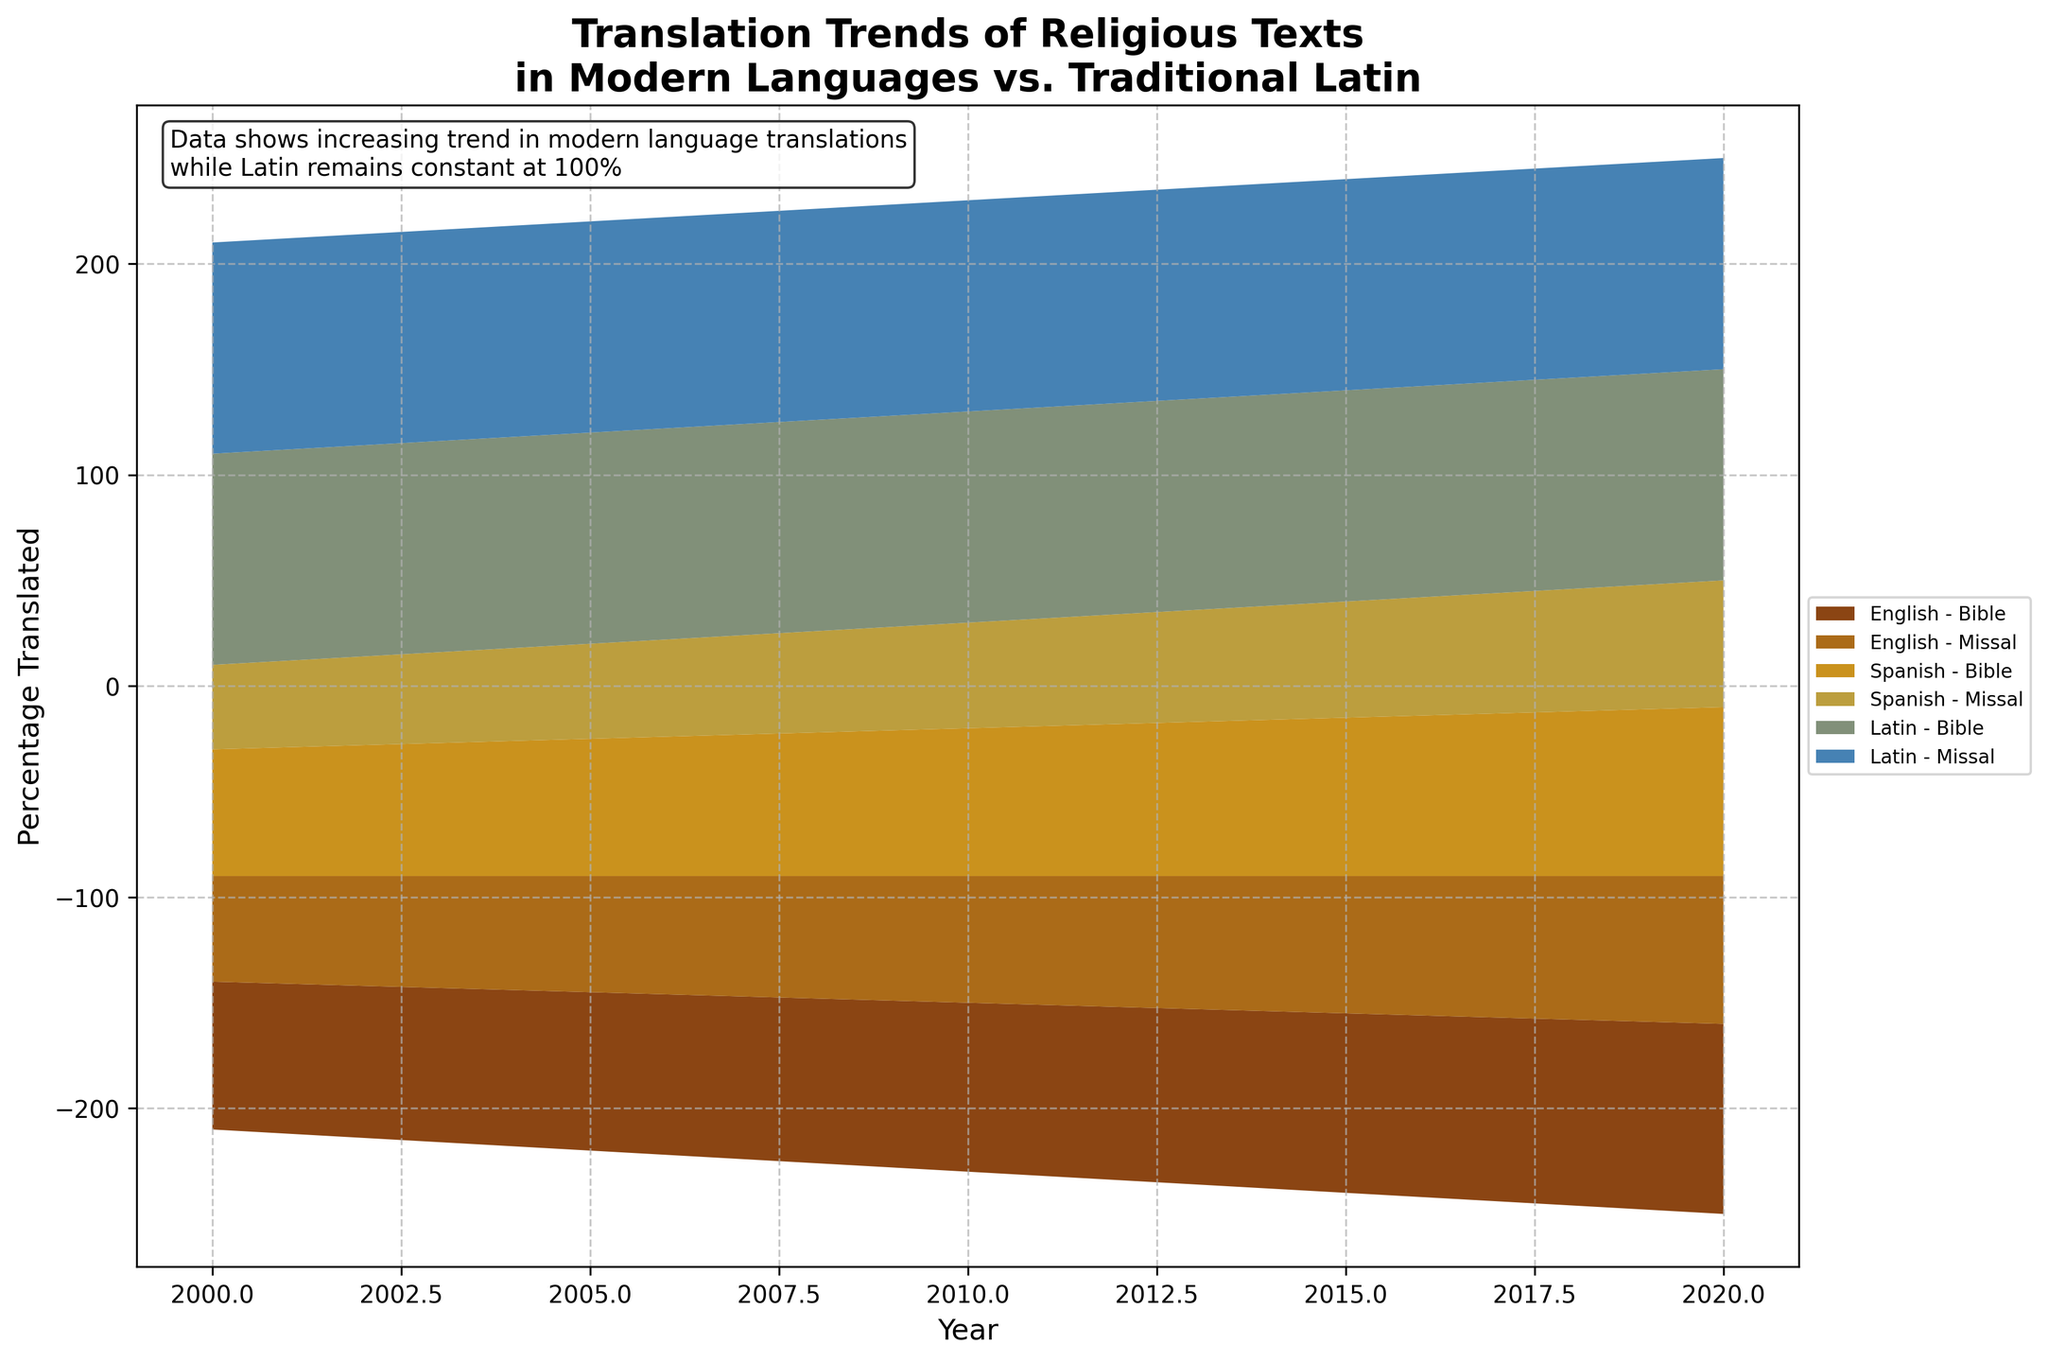What is the general trend in the translation of the Bible into English over the given years? The percentage of Bible translation into English shows a steady increase from 70% in 2000 to 90% in 2020. By looking at the figure, one can observe this upward trend.
Answer: Increasing What percentage of the Missal is translated into Spanish in 2010? By locating the data point for Spanish and Missal in the year 2010, we see that the percentage translated is 50%.
Answer: 50% How does the trend of Bible translation into Spanish compare to that into English? When comparing the trend lines, both English and Spanish show an upward trend, but the translation into English consistently has a higher percentage than Spanish, increasing from 70% to 90% (English) compared to 60% to 80% (Spanish).
Answer: English translations are higher than Spanish, but both increase Has the percentage of Latin translations for both texts changed over the years? Observing the data for Latin translations of both the Bible and Missal, it is evident that the percentage remains constant at 100% throughout all years.
Answer: No, it stays at 100% Between 2000 and 2020, what is the total increase in the percentage translated for the English Missal? The percentage translated for the English Missal in 2000 is 50% and in 2020 is 70%. The total increase is calculated as 70% - 50% = 20%.
Answer: 20% Which religious text has seen the most significant increase in translation in any language from 2000 to 2020? By examining the figure, the English translation of the Bible shows the most significant increase, rising from 70% in 2000 to 90% in 2020, an increase of 20%.
Answer: English Bible What is the percentage difference between the translation of the Missal into English and Spanish in 2005? In 2005, the percentage for English is 55% and for Spanish is 45%. The difference is calculated as 55% - 45% = 10%.
Answer: 10% Is there any year where the percentage translation for the Missal is the same for both English and Spanish? The graph shows that in none of the years the percentage for the Missal translation into English and Spanish is the same. They are different for all years displayed.
Answer: No By how much did the Spanish translation of the Bible increase from 2015 to 2020? The Spanish translation of the Bible in 2015 is 75% and in 2020 is 80%. The increase is calculated as 80% - 75% = 5%.
Answer: 5% Which language shows the smallest increase in its Bible translation percentage over the 20-year period? By inspecting the figure, the Latin Bible translation shows no increase (remaining at 100%), while both English and Spanish show an increase, making Latin the language with the smallest increase in Bible translation percentage.
Answer: Latin 